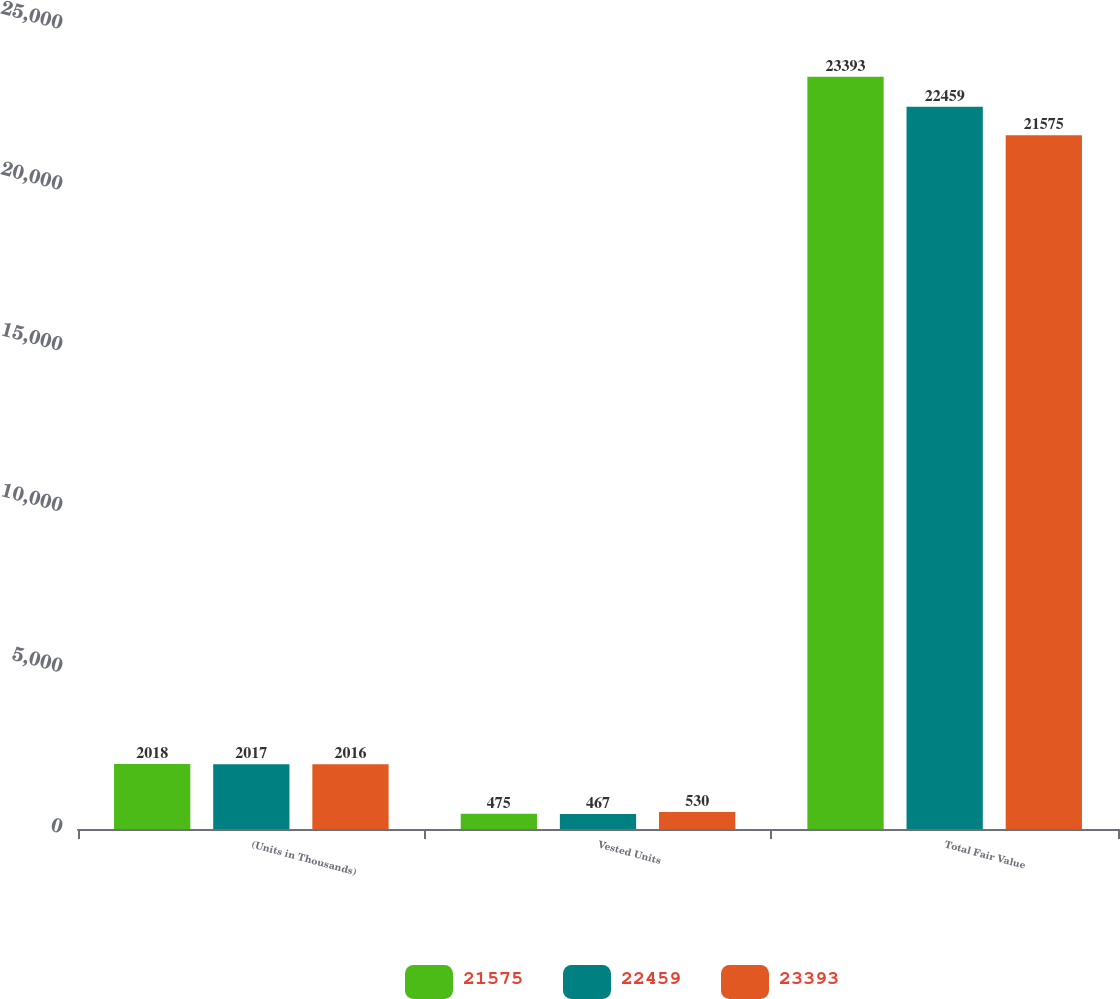Convert chart to OTSL. <chart><loc_0><loc_0><loc_500><loc_500><stacked_bar_chart><ecel><fcel>(Units in Thousands)<fcel>Vested Units<fcel>Total Fair Value<nl><fcel>21575<fcel>2018<fcel>475<fcel>23393<nl><fcel>22459<fcel>2017<fcel>467<fcel>22459<nl><fcel>23393<fcel>2016<fcel>530<fcel>21575<nl></chart> 